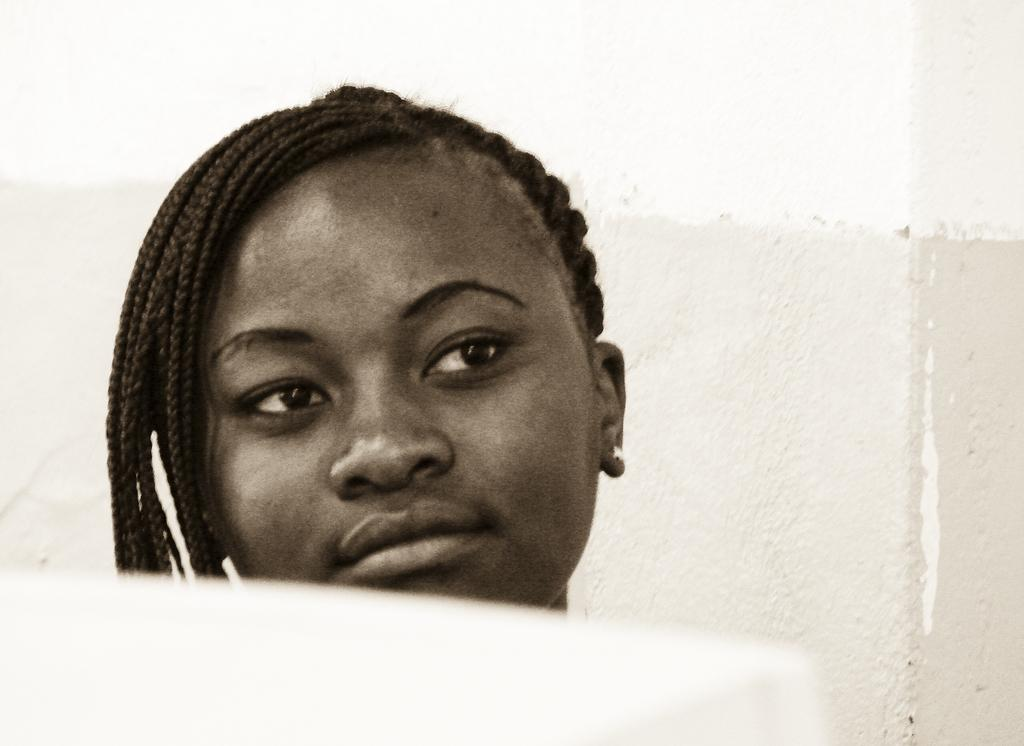Who is the main subject in the image? There is a woman in the image. What is a notable feature of the woman's appearance? The woman has black hair. What can be seen behind the woman in the image? There is a wall behind the woman. What type of orange is the woman holding in the image? There is no orange present in the image; the woman has black hair and is standing in front of a wall. 